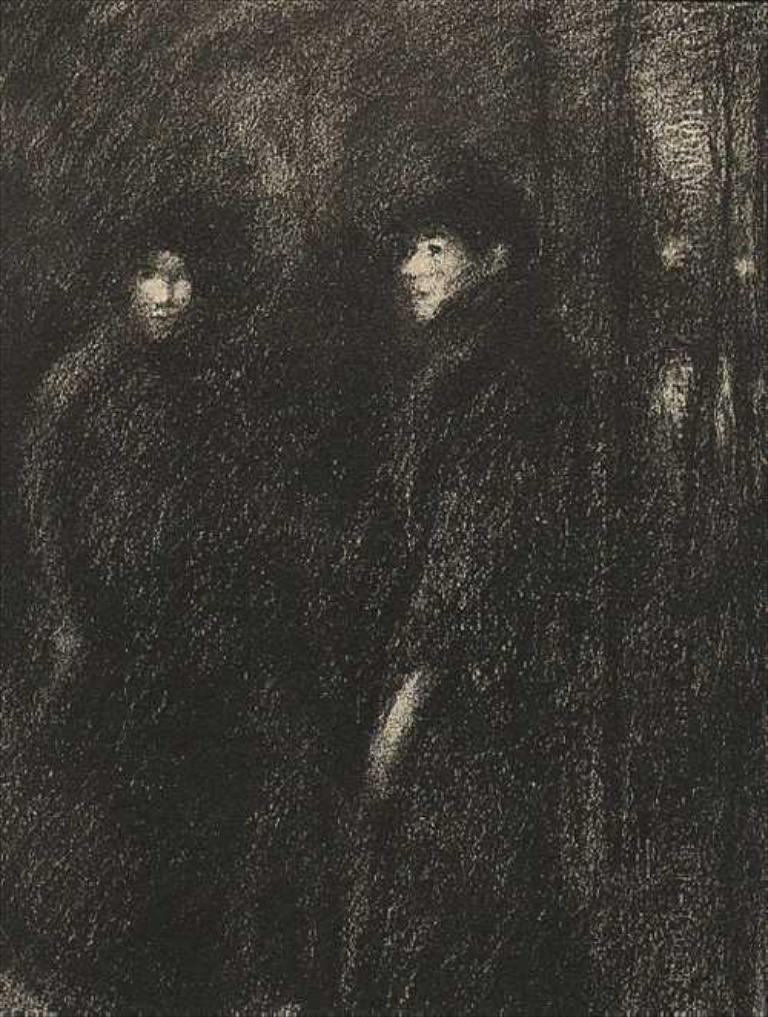What type of artwork is depicted in the image? The image contains a sketch. What type of insect can be seen protesting in the image? There is no insect or protest present in the image; it contains a sketch. What sound does the alarm make in the image? There is no alarm present in the image; it contains a sketch. 